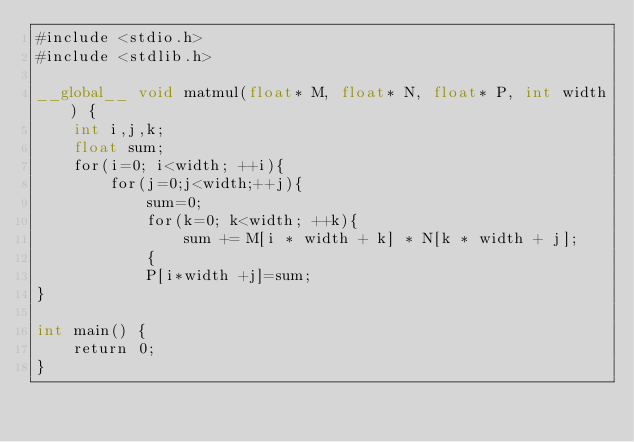Convert code to text. <code><loc_0><loc_0><loc_500><loc_500><_Cuda_>#include <stdio.h>
#include <stdlib.h>

__global__ void matmul(float* M, float* N, float* P, int width) {
    int i,j,k;
    float sum;
    for(i=0; i<width; ++i){
        for(j=0;j<width;++j){
            sum=0;
            for(k=0; k<width; ++k){
                sum += M[i * width + k] * N[k * width + j];
            {
            P[i*width +j]=sum;
}

int main() {
    return 0;
}

</code> 